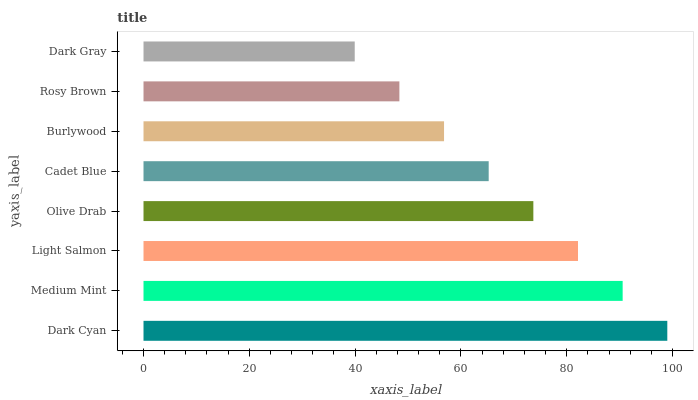Is Dark Gray the minimum?
Answer yes or no. Yes. Is Dark Cyan the maximum?
Answer yes or no. Yes. Is Medium Mint the minimum?
Answer yes or no. No. Is Medium Mint the maximum?
Answer yes or no. No. Is Dark Cyan greater than Medium Mint?
Answer yes or no. Yes. Is Medium Mint less than Dark Cyan?
Answer yes or no. Yes. Is Medium Mint greater than Dark Cyan?
Answer yes or no. No. Is Dark Cyan less than Medium Mint?
Answer yes or no. No. Is Olive Drab the high median?
Answer yes or no. Yes. Is Cadet Blue the low median?
Answer yes or no. Yes. Is Light Salmon the high median?
Answer yes or no. No. Is Light Salmon the low median?
Answer yes or no. No. 